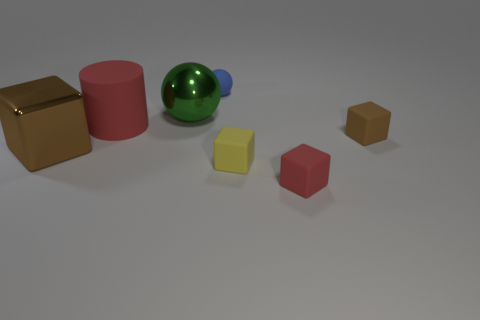Subtract all rubber blocks. How many blocks are left? 1 Add 2 tiny purple metal blocks. How many objects exist? 9 Subtract all cubes. How many objects are left? 3 Subtract all green balls. How many balls are left? 1 Subtract all purple cylinders. How many brown blocks are left? 2 Add 1 tiny red cubes. How many tiny red cubes exist? 2 Subtract 0 red balls. How many objects are left? 7 Subtract 1 cylinders. How many cylinders are left? 0 Subtract all yellow cubes. Subtract all red spheres. How many cubes are left? 3 Subtract all tiny red blocks. Subtract all big red things. How many objects are left? 5 